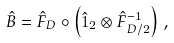Convert formula to latex. <formula><loc_0><loc_0><loc_500><loc_500>\hat { B } = \hat { F } _ { D } \circ \left ( \hat { 1 } _ { 2 } \otimes \hat { F } _ { D / 2 } ^ { - 1 } \right ) \, ,</formula> 